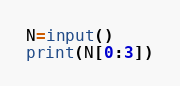<code> <loc_0><loc_0><loc_500><loc_500><_Python_>N=input()
print(N[0:3])</code> 